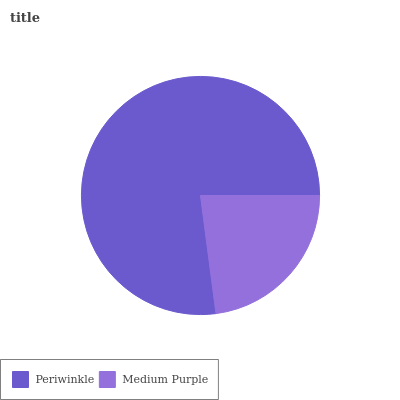Is Medium Purple the minimum?
Answer yes or no. Yes. Is Periwinkle the maximum?
Answer yes or no. Yes. Is Medium Purple the maximum?
Answer yes or no. No. Is Periwinkle greater than Medium Purple?
Answer yes or no. Yes. Is Medium Purple less than Periwinkle?
Answer yes or no. Yes. Is Medium Purple greater than Periwinkle?
Answer yes or no. No. Is Periwinkle less than Medium Purple?
Answer yes or no. No. Is Periwinkle the high median?
Answer yes or no. Yes. Is Medium Purple the low median?
Answer yes or no. Yes. Is Medium Purple the high median?
Answer yes or no. No. Is Periwinkle the low median?
Answer yes or no. No. 